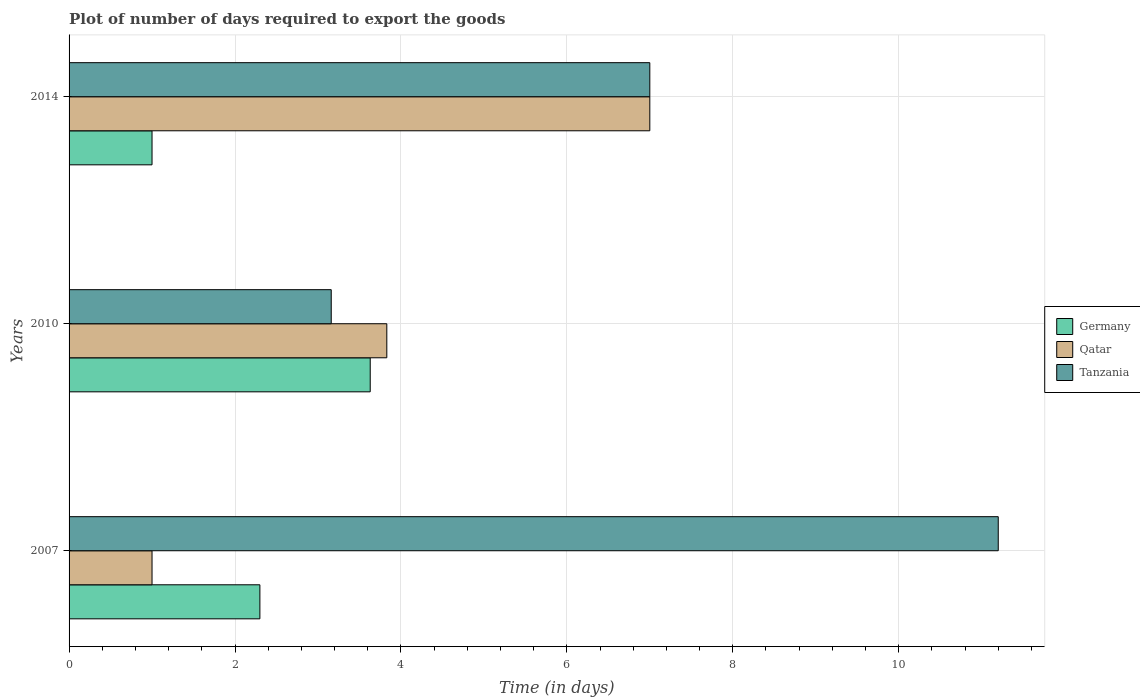How many different coloured bars are there?
Provide a succinct answer. 3. How many bars are there on the 2nd tick from the bottom?
Ensure brevity in your answer.  3. What is the label of the 3rd group of bars from the top?
Keep it short and to the point. 2007. What is the time required to export goods in Tanzania in 2014?
Your answer should be compact. 7. Across all years, what is the maximum time required to export goods in Tanzania?
Keep it short and to the point. 11.2. Across all years, what is the minimum time required to export goods in Qatar?
Offer a very short reply. 1. In which year was the time required to export goods in Tanzania minimum?
Make the answer very short. 2010. What is the total time required to export goods in Germany in the graph?
Your answer should be compact. 6.93. What is the difference between the time required to export goods in Tanzania in 2010 and that in 2014?
Make the answer very short. -3.84. What is the difference between the time required to export goods in Tanzania in 2010 and the time required to export goods in Qatar in 2014?
Offer a terse response. -3.84. What is the average time required to export goods in Tanzania per year?
Your response must be concise. 7.12. In the year 2007, what is the difference between the time required to export goods in Germany and time required to export goods in Tanzania?
Provide a short and direct response. -8.9. What is the ratio of the time required to export goods in Qatar in 2010 to that in 2014?
Offer a terse response. 0.55. Is the time required to export goods in Tanzania in 2010 less than that in 2014?
Make the answer very short. Yes. What is the difference between the highest and the second highest time required to export goods in Germany?
Provide a succinct answer. 1.33. What is the difference between the highest and the lowest time required to export goods in Qatar?
Give a very brief answer. 6. In how many years, is the time required to export goods in Tanzania greater than the average time required to export goods in Tanzania taken over all years?
Ensure brevity in your answer.  1. What does the 1st bar from the top in 2007 represents?
Offer a very short reply. Tanzania. Are all the bars in the graph horizontal?
Your answer should be very brief. Yes. How many years are there in the graph?
Offer a very short reply. 3. What is the difference between two consecutive major ticks on the X-axis?
Keep it short and to the point. 2. Where does the legend appear in the graph?
Your answer should be compact. Center right. How are the legend labels stacked?
Make the answer very short. Vertical. What is the title of the graph?
Provide a succinct answer. Plot of number of days required to export the goods. What is the label or title of the X-axis?
Make the answer very short. Time (in days). What is the Time (in days) of Germany in 2010?
Provide a succinct answer. 3.63. What is the Time (in days) of Qatar in 2010?
Ensure brevity in your answer.  3.83. What is the Time (in days) of Tanzania in 2010?
Your response must be concise. 3.16. What is the Time (in days) of Tanzania in 2014?
Provide a succinct answer. 7. Across all years, what is the maximum Time (in days) of Germany?
Your answer should be very brief. 3.63. Across all years, what is the maximum Time (in days) in Qatar?
Offer a very short reply. 7. Across all years, what is the minimum Time (in days) in Germany?
Keep it short and to the point. 1. Across all years, what is the minimum Time (in days) in Tanzania?
Your response must be concise. 3.16. What is the total Time (in days) of Germany in the graph?
Offer a very short reply. 6.93. What is the total Time (in days) of Qatar in the graph?
Offer a terse response. 11.83. What is the total Time (in days) in Tanzania in the graph?
Provide a succinct answer. 21.36. What is the difference between the Time (in days) in Germany in 2007 and that in 2010?
Your response must be concise. -1.33. What is the difference between the Time (in days) in Qatar in 2007 and that in 2010?
Your response must be concise. -2.83. What is the difference between the Time (in days) of Tanzania in 2007 and that in 2010?
Your answer should be compact. 8.04. What is the difference between the Time (in days) in Germany in 2007 and that in 2014?
Your response must be concise. 1.3. What is the difference between the Time (in days) in Tanzania in 2007 and that in 2014?
Your answer should be compact. 4.2. What is the difference between the Time (in days) in Germany in 2010 and that in 2014?
Your response must be concise. 2.63. What is the difference between the Time (in days) in Qatar in 2010 and that in 2014?
Your response must be concise. -3.17. What is the difference between the Time (in days) in Tanzania in 2010 and that in 2014?
Provide a short and direct response. -3.84. What is the difference between the Time (in days) of Germany in 2007 and the Time (in days) of Qatar in 2010?
Provide a succinct answer. -1.53. What is the difference between the Time (in days) of Germany in 2007 and the Time (in days) of Tanzania in 2010?
Offer a terse response. -0.86. What is the difference between the Time (in days) of Qatar in 2007 and the Time (in days) of Tanzania in 2010?
Your answer should be compact. -2.16. What is the difference between the Time (in days) in Germany in 2007 and the Time (in days) in Qatar in 2014?
Give a very brief answer. -4.7. What is the difference between the Time (in days) in Germany in 2007 and the Time (in days) in Tanzania in 2014?
Your response must be concise. -4.7. What is the difference between the Time (in days) of Qatar in 2007 and the Time (in days) of Tanzania in 2014?
Offer a very short reply. -6. What is the difference between the Time (in days) of Germany in 2010 and the Time (in days) of Qatar in 2014?
Your response must be concise. -3.37. What is the difference between the Time (in days) in Germany in 2010 and the Time (in days) in Tanzania in 2014?
Your answer should be compact. -3.37. What is the difference between the Time (in days) of Qatar in 2010 and the Time (in days) of Tanzania in 2014?
Offer a very short reply. -3.17. What is the average Time (in days) in Germany per year?
Your answer should be compact. 2.31. What is the average Time (in days) in Qatar per year?
Provide a short and direct response. 3.94. What is the average Time (in days) of Tanzania per year?
Offer a very short reply. 7.12. In the year 2007, what is the difference between the Time (in days) of Germany and Time (in days) of Qatar?
Your answer should be compact. 1.3. In the year 2007, what is the difference between the Time (in days) of Qatar and Time (in days) of Tanzania?
Make the answer very short. -10.2. In the year 2010, what is the difference between the Time (in days) of Germany and Time (in days) of Tanzania?
Your response must be concise. 0.47. In the year 2010, what is the difference between the Time (in days) of Qatar and Time (in days) of Tanzania?
Make the answer very short. 0.67. In the year 2014, what is the difference between the Time (in days) in Germany and Time (in days) in Tanzania?
Ensure brevity in your answer.  -6. What is the ratio of the Time (in days) in Germany in 2007 to that in 2010?
Keep it short and to the point. 0.63. What is the ratio of the Time (in days) of Qatar in 2007 to that in 2010?
Your response must be concise. 0.26. What is the ratio of the Time (in days) of Tanzania in 2007 to that in 2010?
Your answer should be very brief. 3.54. What is the ratio of the Time (in days) in Germany in 2007 to that in 2014?
Give a very brief answer. 2.3. What is the ratio of the Time (in days) in Qatar in 2007 to that in 2014?
Give a very brief answer. 0.14. What is the ratio of the Time (in days) of Tanzania in 2007 to that in 2014?
Offer a terse response. 1.6. What is the ratio of the Time (in days) in Germany in 2010 to that in 2014?
Your answer should be very brief. 3.63. What is the ratio of the Time (in days) of Qatar in 2010 to that in 2014?
Keep it short and to the point. 0.55. What is the ratio of the Time (in days) in Tanzania in 2010 to that in 2014?
Make the answer very short. 0.45. What is the difference between the highest and the second highest Time (in days) of Germany?
Your answer should be very brief. 1.33. What is the difference between the highest and the second highest Time (in days) in Qatar?
Give a very brief answer. 3.17. What is the difference between the highest and the second highest Time (in days) of Tanzania?
Provide a short and direct response. 4.2. What is the difference between the highest and the lowest Time (in days) in Germany?
Make the answer very short. 2.63. What is the difference between the highest and the lowest Time (in days) of Tanzania?
Offer a terse response. 8.04. 